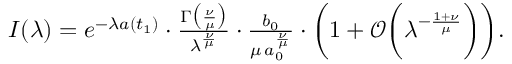<formula> <loc_0><loc_0><loc_500><loc_500>\begin{array} { r } { I ( \lambda ) = e ^ { - \lambda a ( t _ { 1 } ) } \cdot \frac { \Gamma \left ( \frac { \nu } { \mu } \right ) } { \lambda ^ { \frac { \nu } { \mu } } } \cdot \frac { b _ { 0 } } { \mu \, a _ { 0 } ^ { \frac { \nu } { \mu } } } \cdot \left ( 1 + \mathcal { O } \left ( \lambda ^ { - \frac { 1 + \nu } { \mu } } \right ) \right ) . } \end{array}</formula> 